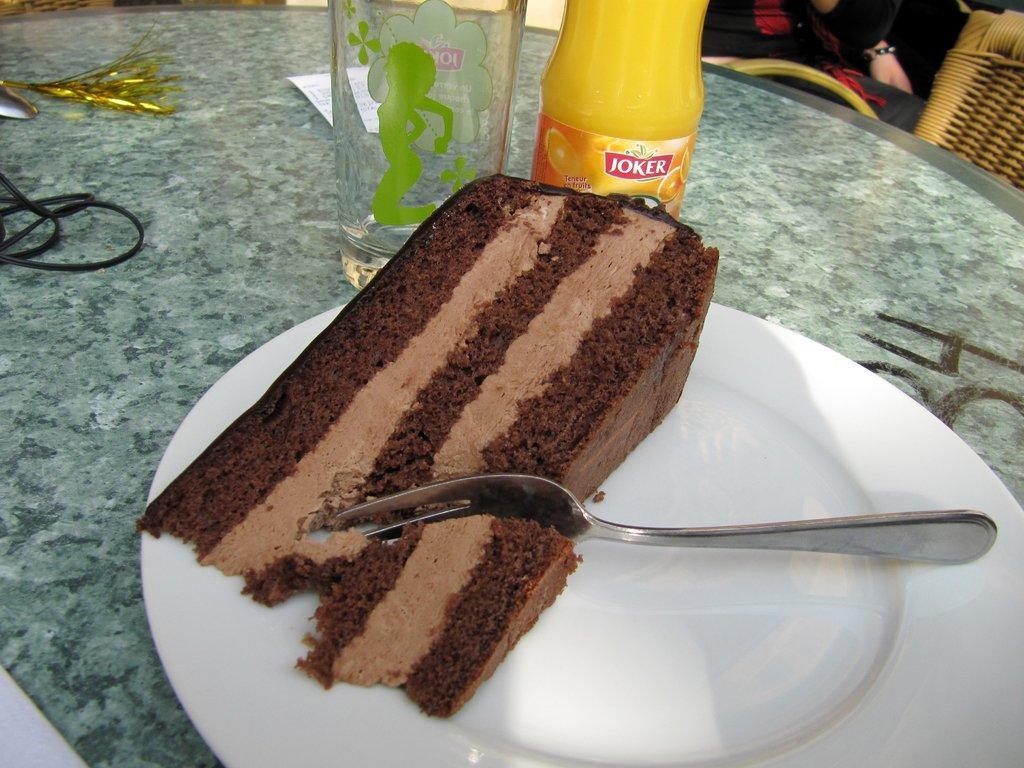Describe this image in one or two sentences. In this image I can see a white colour plate in the front and on it I can see a piece of a cake and a fork. On the top side of this image I can see few bottles, a white colour paper and few other stuff on the table. On the top right corner of this image I can see a chair and few persons. 